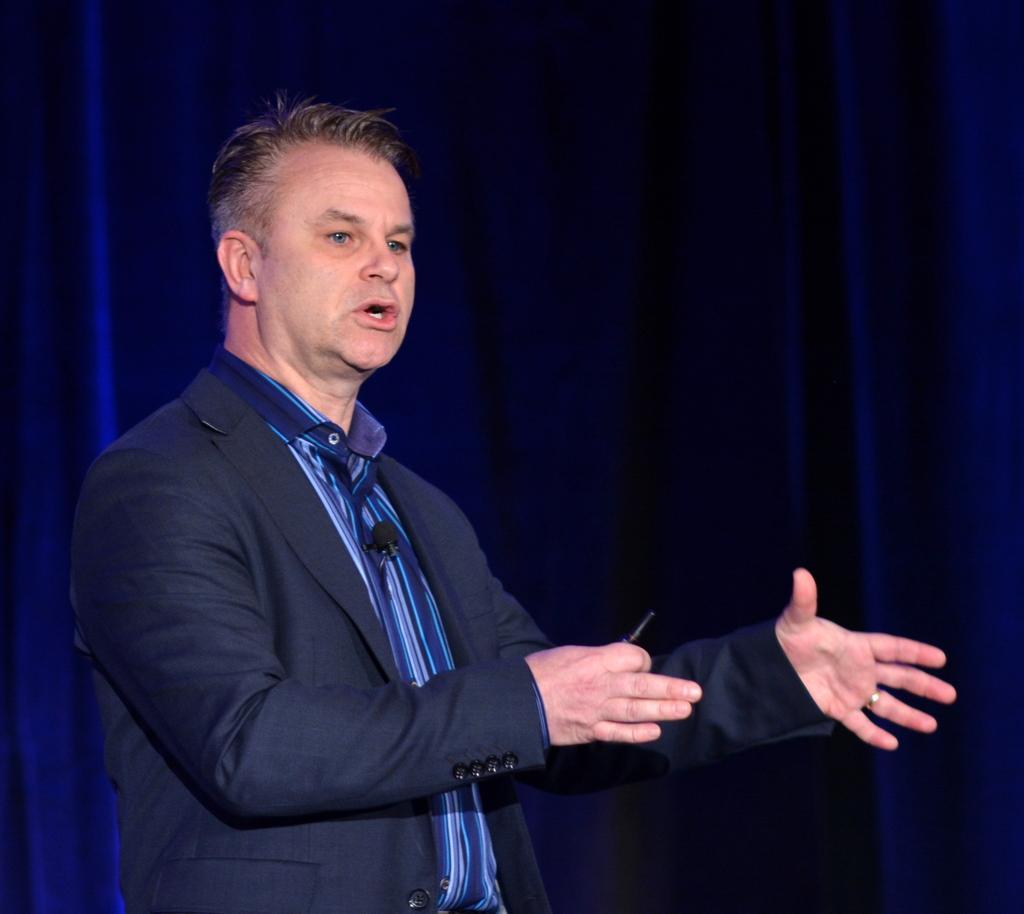Please provide a concise description of this image. In this picture there is a person wearing a blue jacket and talking. In the background there are blue curtains. 